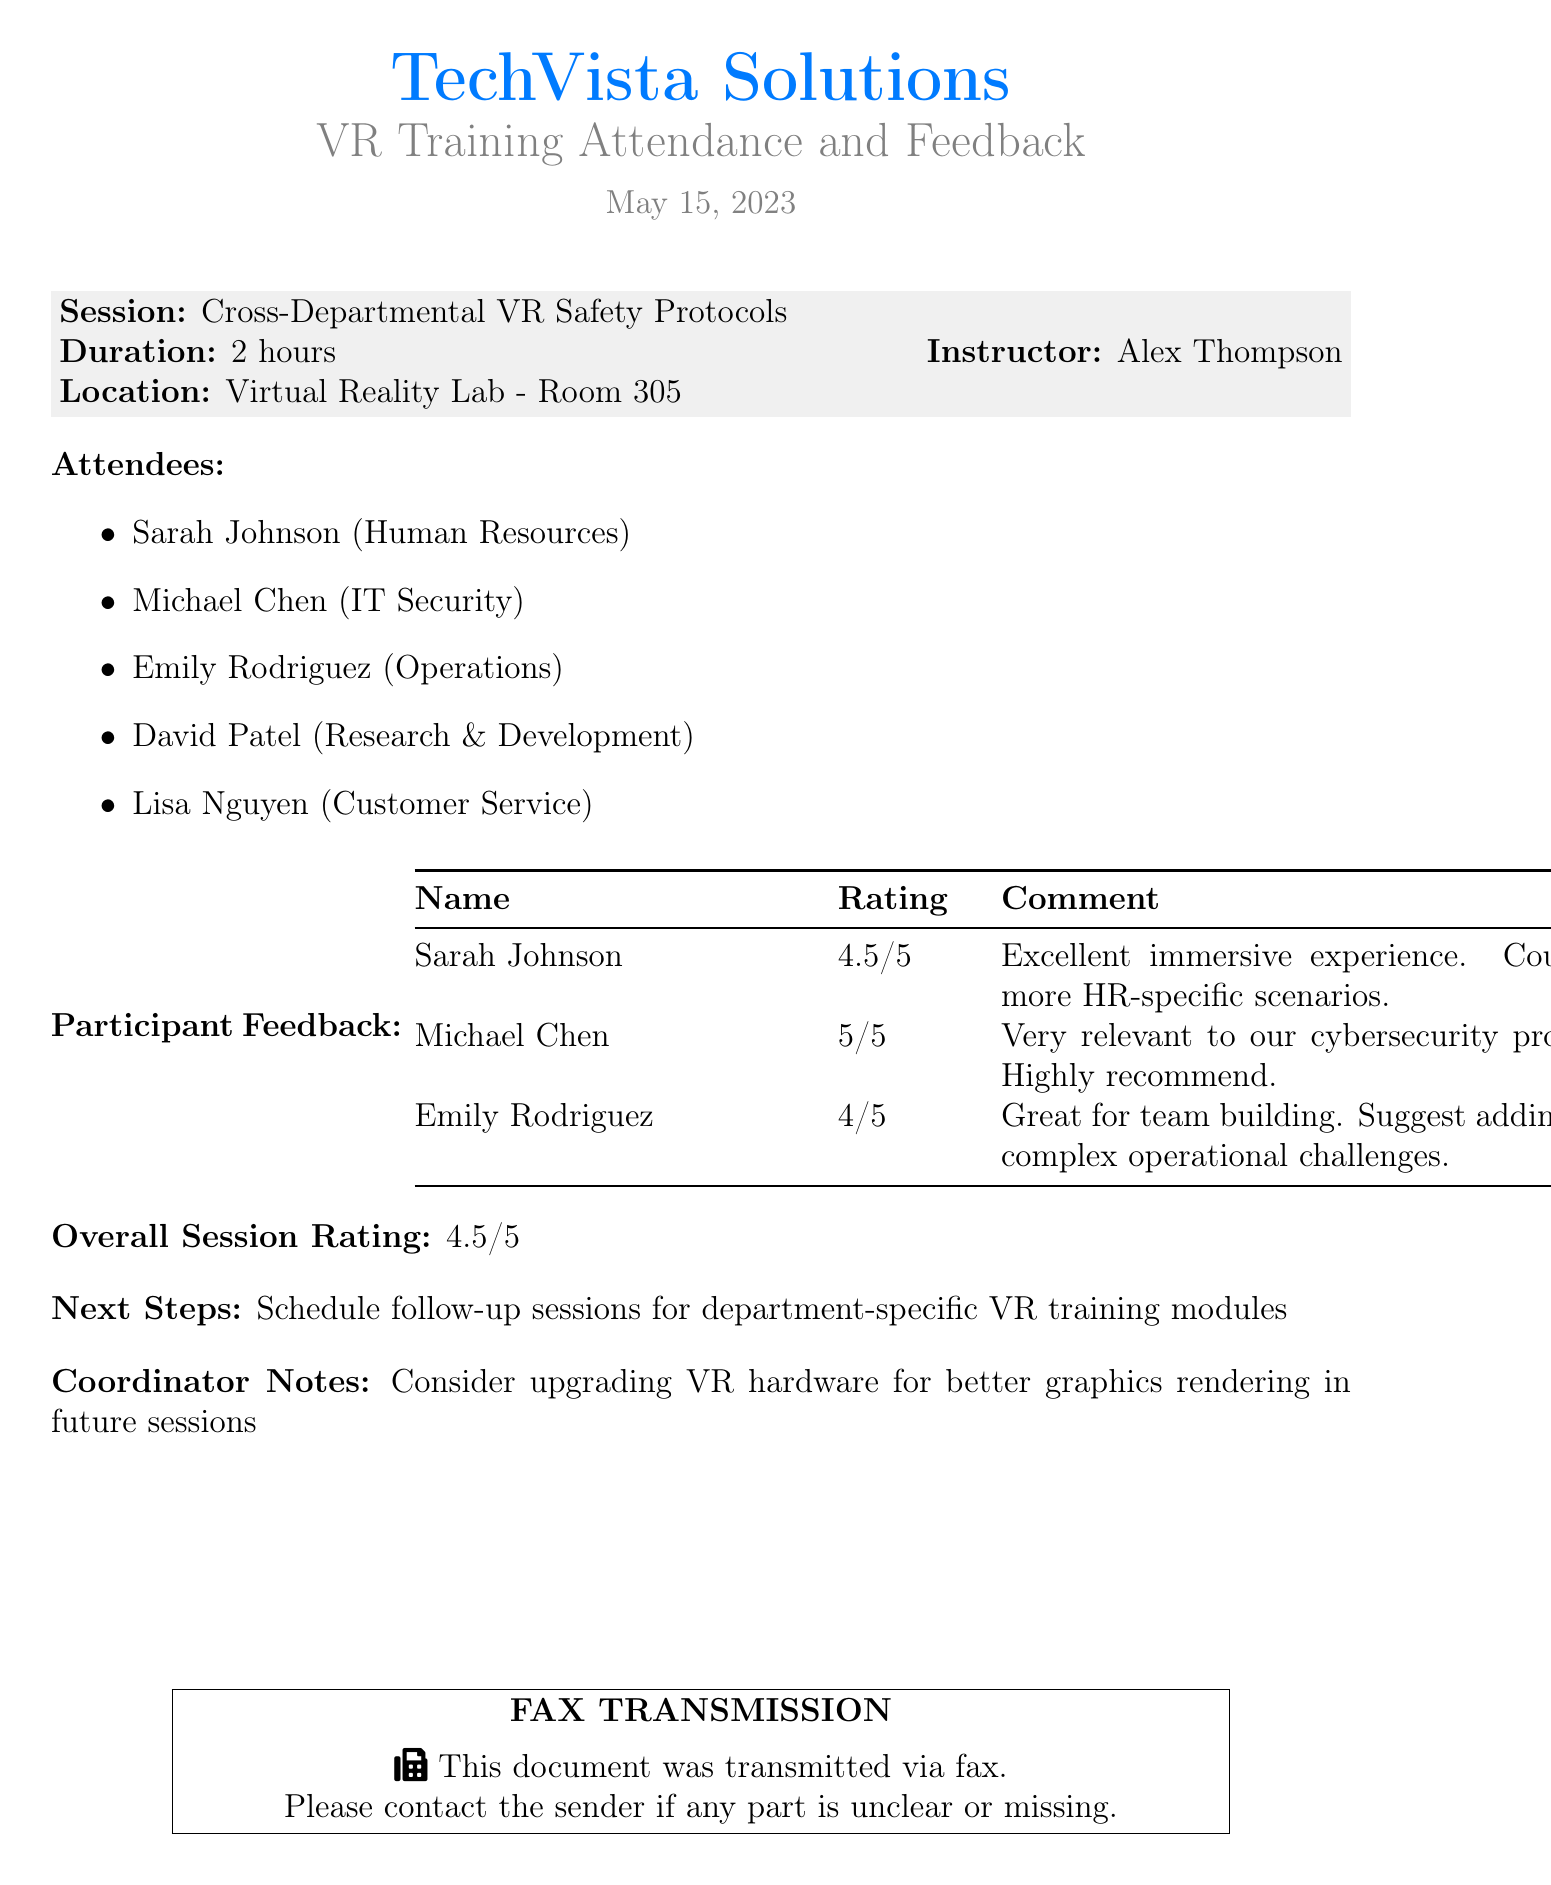What was the date of the training session? The date of the training session is specified in the document under the title, which is May 15, 2023.
Answer: May 15, 2023 Who was the instructor for the session? The instructor is mentioned in the session details, which is Alex Thompson.
Answer: Alex Thompson How many attendees were present? The number of attendees can be counted from the list provided in the document, which includes five names.
Answer: 5 What was the overall session rating? The overall session rating is mentioned at the end of the feedback section, which is 4.5 out of 5.
Answer: 4.5/5 What type of feedback did Michael Chen give? The feedback provided by Michael Chen includes a specific rating and endorsement, which is "Very relevant to our cybersecurity protocols. Highly recommend."
Answer: 5/5 What is one suggested next step mentioned in the document? One of the next steps noted in the document is to "Schedule follow-up sessions for department-specific VR training modules."
Answer: Schedule follow-up sessions What department does Sarah Johnson belong to? The document lists Sarah Johnson under the attendees with her associated department being Human Resources.
Answer: Human Resources What was a suggested improvement mentioned in the coordinator notes? The coordinator notes include a suggestion to "Consider upgrading VR hardware for better graphics rendering in future sessions."
Answer: Upgrading VR hardware 